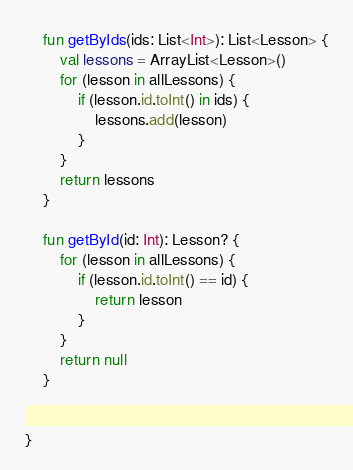Convert code to text. <code><loc_0><loc_0><loc_500><loc_500><_Kotlin_>    fun getByIds(ids: List<Int>): List<Lesson> {
        val lessons = ArrayList<Lesson>()
        for (lesson in allLessons) {
            if (lesson.id.toInt() in ids) {
                lessons.add(lesson)
            }
        }
        return lessons
    }

    fun getById(id: Int): Lesson? {
        for (lesson in allLessons) {
            if (lesson.id.toInt() == id) {
                return lesson
            }
        }
        return null
    }


}
</code> 